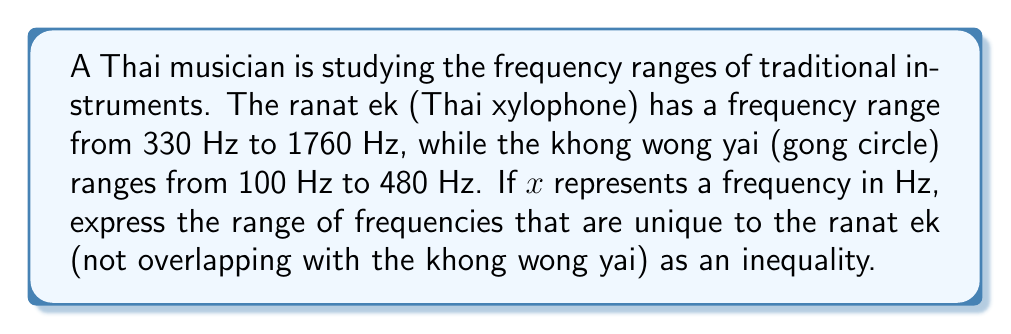Solve this math problem. To solve this problem, we need to follow these steps:

1) First, let's identify the overlapping range:
   The khong wong yai's upper limit (480 Hz) is within the ranat ek's range.

2) The frequencies unique to the ranat ek will be those above 480 Hz.

3) We can express this as an inequality:
   $x > 480$

4) However, we also need to consider the upper limit of the ranat ek:
   $x \leq 1760$

5) Combining these conditions, we get:
   $480 < x \leq 1760$

This inequality represents all frequencies that are unique to the ranat ek, i.e., higher than the khong wong yai's range but within the ranat ek's range.
Answer: $480 < x \leq 1760$ 